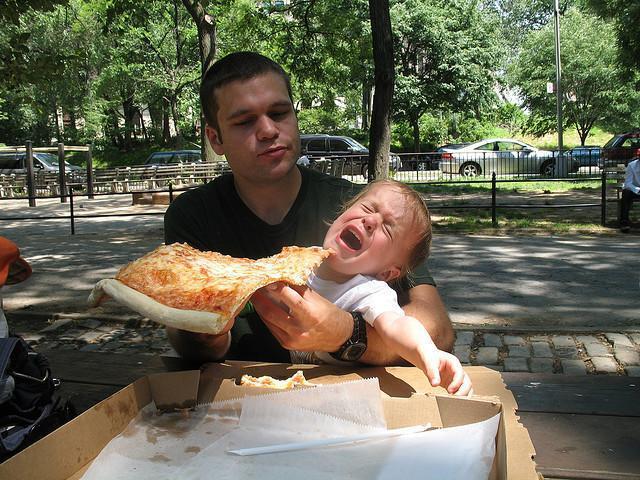How many cars are red?
Give a very brief answer. 0. How many cars are there?
Give a very brief answer. 2. How many people are there?
Give a very brief answer. 2. How many benches are in the photo?
Give a very brief answer. 2. 